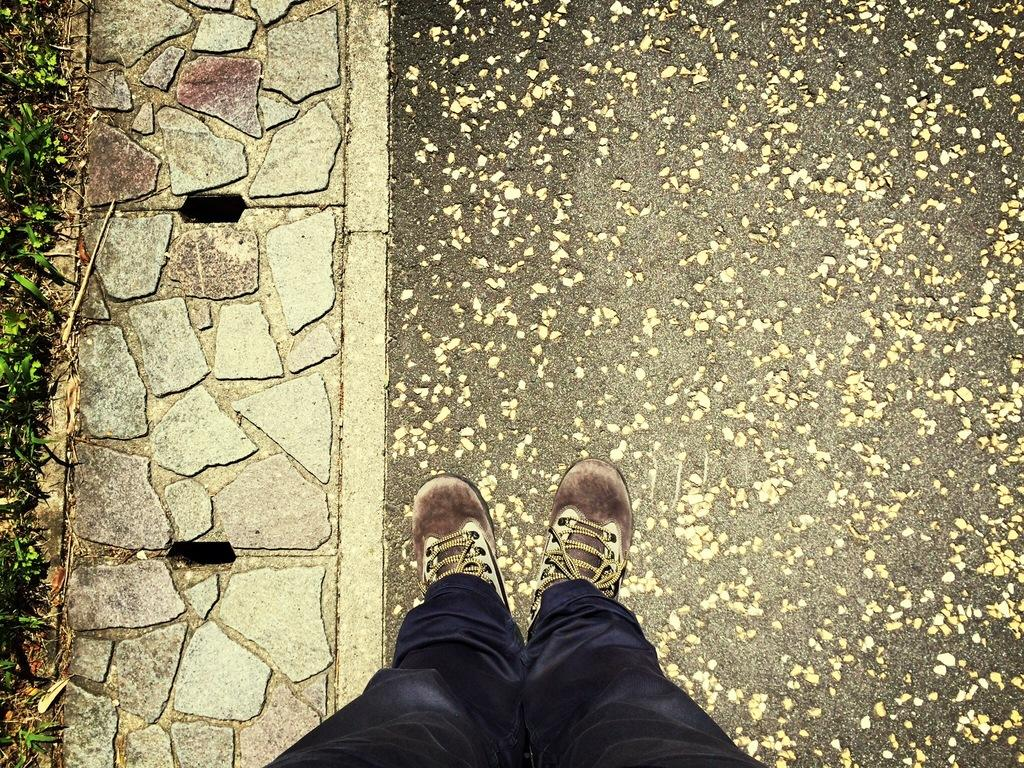What part of a person can be seen in the image? There are legs of a person visible in the image. Where are the legs located in relation to the floor? The legs are on the floor. What type of cable is being destroyed by the person's neck in the image? There is no cable or destruction present in the image; it only shows a person's legs visible on the floor. 